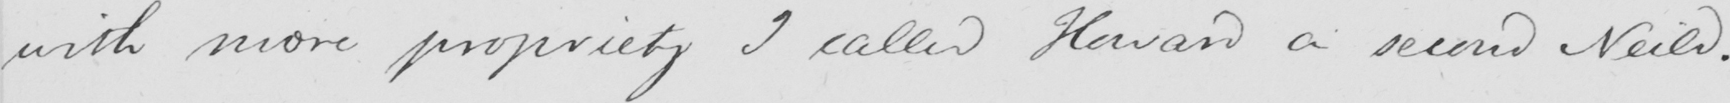What does this handwritten line say? with more propriety I called Howard a second Neild . 